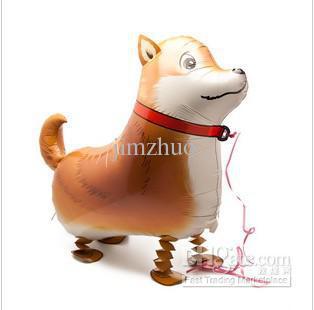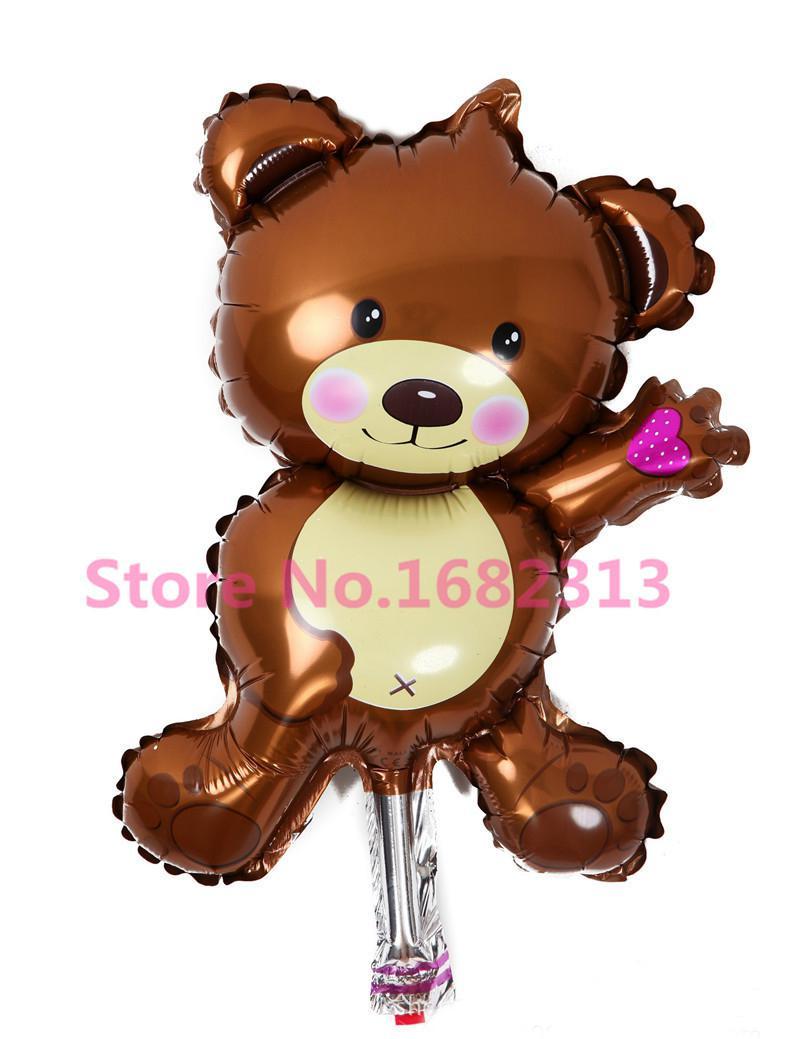The first image is the image on the left, the second image is the image on the right. For the images shown, is this caption "One of the balloons is a dog that is wearing a collar and standing on four folded paper legs." true? Answer yes or no. Yes. 